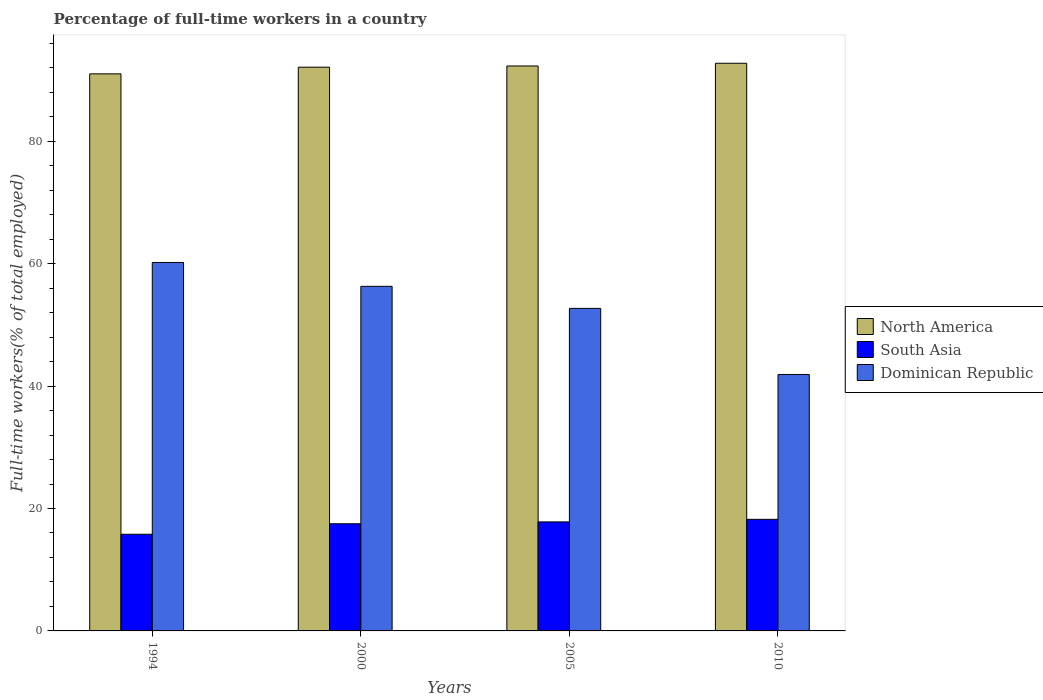Are the number of bars per tick equal to the number of legend labels?
Offer a very short reply. Yes. How many bars are there on the 4th tick from the left?
Give a very brief answer. 3. In how many cases, is the number of bars for a given year not equal to the number of legend labels?
Provide a short and direct response. 0. What is the percentage of full-time workers in South Asia in 2000?
Give a very brief answer. 17.51. Across all years, what is the maximum percentage of full-time workers in North America?
Give a very brief answer. 92.75. Across all years, what is the minimum percentage of full-time workers in Dominican Republic?
Offer a terse response. 41.9. What is the total percentage of full-time workers in North America in the graph?
Your response must be concise. 368.18. What is the difference between the percentage of full-time workers in South Asia in 2000 and that in 2005?
Ensure brevity in your answer.  -0.3. What is the difference between the percentage of full-time workers in North America in 2010 and the percentage of full-time workers in South Asia in 2005?
Your response must be concise. 74.94. What is the average percentage of full-time workers in North America per year?
Ensure brevity in your answer.  92.05. In the year 1994, what is the difference between the percentage of full-time workers in South Asia and percentage of full-time workers in North America?
Your answer should be very brief. -75.22. In how many years, is the percentage of full-time workers in South Asia greater than 88 %?
Offer a terse response. 0. What is the ratio of the percentage of full-time workers in North America in 2000 to that in 2005?
Keep it short and to the point. 1. Is the difference between the percentage of full-time workers in South Asia in 1994 and 2000 greater than the difference between the percentage of full-time workers in North America in 1994 and 2000?
Your response must be concise. No. What is the difference between the highest and the second highest percentage of full-time workers in South Asia?
Make the answer very short. 0.42. What is the difference between the highest and the lowest percentage of full-time workers in Dominican Republic?
Offer a very short reply. 18.3. What does the 2nd bar from the right in 1994 represents?
Give a very brief answer. South Asia. Is it the case that in every year, the sum of the percentage of full-time workers in North America and percentage of full-time workers in Dominican Republic is greater than the percentage of full-time workers in South Asia?
Offer a very short reply. Yes. Are all the bars in the graph horizontal?
Your answer should be compact. No. Are the values on the major ticks of Y-axis written in scientific E-notation?
Your answer should be very brief. No. Does the graph contain any zero values?
Your answer should be compact. No. Does the graph contain grids?
Offer a terse response. No. Where does the legend appear in the graph?
Your answer should be compact. Center right. What is the title of the graph?
Provide a short and direct response. Percentage of full-time workers in a country. What is the label or title of the X-axis?
Your answer should be compact. Years. What is the label or title of the Y-axis?
Your answer should be very brief. Full-time workers(% of total employed). What is the Full-time workers(% of total employed) in North America in 1994?
Provide a succinct answer. 91.02. What is the Full-time workers(% of total employed) of South Asia in 1994?
Keep it short and to the point. 15.79. What is the Full-time workers(% of total employed) of Dominican Republic in 1994?
Your answer should be very brief. 60.2. What is the Full-time workers(% of total employed) in North America in 2000?
Provide a succinct answer. 92.11. What is the Full-time workers(% of total employed) in South Asia in 2000?
Your answer should be very brief. 17.51. What is the Full-time workers(% of total employed) of Dominican Republic in 2000?
Make the answer very short. 56.3. What is the Full-time workers(% of total employed) in North America in 2005?
Your answer should be very brief. 92.31. What is the Full-time workers(% of total employed) of South Asia in 2005?
Ensure brevity in your answer.  17.81. What is the Full-time workers(% of total employed) in Dominican Republic in 2005?
Provide a short and direct response. 52.7. What is the Full-time workers(% of total employed) of North America in 2010?
Offer a terse response. 92.75. What is the Full-time workers(% of total employed) in South Asia in 2010?
Your response must be concise. 18.23. What is the Full-time workers(% of total employed) of Dominican Republic in 2010?
Your response must be concise. 41.9. Across all years, what is the maximum Full-time workers(% of total employed) of North America?
Your response must be concise. 92.75. Across all years, what is the maximum Full-time workers(% of total employed) in South Asia?
Provide a short and direct response. 18.23. Across all years, what is the maximum Full-time workers(% of total employed) of Dominican Republic?
Keep it short and to the point. 60.2. Across all years, what is the minimum Full-time workers(% of total employed) in North America?
Your answer should be compact. 91.02. Across all years, what is the minimum Full-time workers(% of total employed) of South Asia?
Offer a terse response. 15.79. Across all years, what is the minimum Full-time workers(% of total employed) of Dominican Republic?
Provide a succinct answer. 41.9. What is the total Full-time workers(% of total employed) of North America in the graph?
Provide a short and direct response. 368.18. What is the total Full-time workers(% of total employed) in South Asia in the graph?
Keep it short and to the point. 69.35. What is the total Full-time workers(% of total employed) in Dominican Republic in the graph?
Your answer should be compact. 211.1. What is the difference between the Full-time workers(% of total employed) in North America in 1994 and that in 2000?
Make the answer very short. -1.09. What is the difference between the Full-time workers(% of total employed) in South Asia in 1994 and that in 2000?
Offer a terse response. -1.72. What is the difference between the Full-time workers(% of total employed) of North America in 1994 and that in 2005?
Offer a very short reply. -1.29. What is the difference between the Full-time workers(% of total employed) in South Asia in 1994 and that in 2005?
Offer a terse response. -2.02. What is the difference between the Full-time workers(% of total employed) in North America in 1994 and that in 2010?
Keep it short and to the point. -1.73. What is the difference between the Full-time workers(% of total employed) of South Asia in 1994 and that in 2010?
Provide a succinct answer. -2.44. What is the difference between the Full-time workers(% of total employed) of Dominican Republic in 1994 and that in 2010?
Provide a succinct answer. 18.3. What is the difference between the Full-time workers(% of total employed) of North America in 2000 and that in 2005?
Ensure brevity in your answer.  -0.2. What is the difference between the Full-time workers(% of total employed) of South Asia in 2000 and that in 2005?
Provide a succinct answer. -0.3. What is the difference between the Full-time workers(% of total employed) of North America in 2000 and that in 2010?
Your answer should be compact. -0.64. What is the difference between the Full-time workers(% of total employed) of South Asia in 2000 and that in 2010?
Offer a very short reply. -0.72. What is the difference between the Full-time workers(% of total employed) of North America in 2005 and that in 2010?
Provide a succinct answer. -0.44. What is the difference between the Full-time workers(% of total employed) of South Asia in 2005 and that in 2010?
Your response must be concise. -0.42. What is the difference between the Full-time workers(% of total employed) in North America in 1994 and the Full-time workers(% of total employed) in South Asia in 2000?
Keep it short and to the point. 73.51. What is the difference between the Full-time workers(% of total employed) of North America in 1994 and the Full-time workers(% of total employed) of Dominican Republic in 2000?
Your response must be concise. 34.72. What is the difference between the Full-time workers(% of total employed) of South Asia in 1994 and the Full-time workers(% of total employed) of Dominican Republic in 2000?
Your answer should be compact. -40.51. What is the difference between the Full-time workers(% of total employed) in North America in 1994 and the Full-time workers(% of total employed) in South Asia in 2005?
Keep it short and to the point. 73.2. What is the difference between the Full-time workers(% of total employed) of North America in 1994 and the Full-time workers(% of total employed) of Dominican Republic in 2005?
Provide a succinct answer. 38.32. What is the difference between the Full-time workers(% of total employed) of South Asia in 1994 and the Full-time workers(% of total employed) of Dominican Republic in 2005?
Make the answer very short. -36.91. What is the difference between the Full-time workers(% of total employed) in North America in 1994 and the Full-time workers(% of total employed) in South Asia in 2010?
Provide a short and direct response. 72.79. What is the difference between the Full-time workers(% of total employed) of North America in 1994 and the Full-time workers(% of total employed) of Dominican Republic in 2010?
Provide a short and direct response. 49.12. What is the difference between the Full-time workers(% of total employed) of South Asia in 1994 and the Full-time workers(% of total employed) of Dominican Republic in 2010?
Give a very brief answer. -26.11. What is the difference between the Full-time workers(% of total employed) of North America in 2000 and the Full-time workers(% of total employed) of South Asia in 2005?
Ensure brevity in your answer.  74.3. What is the difference between the Full-time workers(% of total employed) of North America in 2000 and the Full-time workers(% of total employed) of Dominican Republic in 2005?
Keep it short and to the point. 39.41. What is the difference between the Full-time workers(% of total employed) in South Asia in 2000 and the Full-time workers(% of total employed) in Dominican Republic in 2005?
Make the answer very short. -35.19. What is the difference between the Full-time workers(% of total employed) in North America in 2000 and the Full-time workers(% of total employed) in South Asia in 2010?
Ensure brevity in your answer.  73.88. What is the difference between the Full-time workers(% of total employed) of North America in 2000 and the Full-time workers(% of total employed) of Dominican Republic in 2010?
Provide a short and direct response. 50.21. What is the difference between the Full-time workers(% of total employed) in South Asia in 2000 and the Full-time workers(% of total employed) in Dominican Republic in 2010?
Keep it short and to the point. -24.39. What is the difference between the Full-time workers(% of total employed) of North America in 2005 and the Full-time workers(% of total employed) of South Asia in 2010?
Keep it short and to the point. 74.07. What is the difference between the Full-time workers(% of total employed) of North America in 2005 and the Full-time workers(% of total employed) of Dominican Republic in 2010?
Provide a short and direct response. 50.41. What is the difference between the Full-time workers(% of total employed) in South Asia in 2005 and the Full-time workers(% of total employed) in Dominican Republic in 2010?
Give a very brief answer. -24.09. What is the average Full-time workers(% of total employed) in North America per year?
Offer a terse response. 92.05. What is the average Full-time workers(% of total employed) of South Asia per year?
Provide a short and direct response. 17.34. What is the average Full-time workers(% of total employed) in Dominican Republic per year?
Keep it short and to the point. 52.77. In the year 1994, what is the difference between the Full-time workers(% of total employed) in North America and Full-time workers(% of total employed) in South Asia?
Provide a succinct answer. 75.22. In the year 1994, what is the difference between the Full-time workers(% of total employed) in North America and Full-time workers(% of total employed) in Dominican Republic?
Your response must be concise. 30.82. In the year 1994, what is the difference between the Full-time workers(% of total employed) in South Asia and Full-time workers(% of total employed) in Dominican Republic?
Offer a very short reply. -44.41. In the year 2000, what is the difference between the Full-time workers(% of total employed) in North America and Full-time workers(% of total employed) in South Asia?
Give a very brief answer. 74.6. In the year 2000, what is the difference between the Full-time workers(% of total employed) of North America and Full-time workers(% of total employed) of Dominican Republic?
Offer a terse response. 35.81. In the year 2000, what is the difference between the Full-time workers(% of total employed) in South Asia and Full-time workers(% of total employed) in Dominican Republic?
Your response must be concise. -38.79. In the year 2005, what is the difference between the Full-time workers(% of total employed) of North America and Full-time workers(% of total employed) of South Asia?
Offer a very short reply. 74.49. In the year 2005, what is the difference between the Full-time workers(% of total employed) of North America and Full-time workers(% of total employed) of Dominican Republic?
Keep it short and to the point. 39.61. In the year 2005, what is the difference between the Full-time workers(% of total employed) of South Asia and Full-time workers(% of total employed) of Dominican Republic?
Provide a succinct answer. -34.89. In the year 2010, what is the difference between the Full-time workers(% of total employed) of North America and Full-time workers(% of total employed) of South Asia?
Offer a terse response. 74.52. In the year 2010, what is the difference between the Full-time workers(% of total employed) of North America and Full-time workers(% of total employed) of Dominican Republic?
Your answer should be compact. 50.85. In the year 2010, what is the difference between the Full-time workers(% of total employed) in South Asia and Full-time workers(% of total employed) in Dominican Republic?
Your answer should be compact. -23.67. What is the ratio of the Full-time workers(% of total employed) of South Asia in 1994 to that in 2000?
Give a very brief answer. 0.9. What is the ratio of the Full-time workers(% of total employed) in Dominican Republic in 1994 to that in 2000?
Your response must be concise. 1.07. What is the ratio of the Full-time workers(% of total employed) of North America in 1994 to that in 2005?
Make the answer very short. 0.99. What is the ratio of the Full-time workers(% of total employed) of South Asia in 1994 to that in 2005?
Make the answer very short. 0.89. What is the ratio of the Full-time workers(% of total employed) of Dominican Republic in 1994 to that in 2005?
Offer a terse response. 1.14. What is the ratio of the Full-time workers(% of total employed) of North America in 1994 to that in 2010?
Your answer should be very brief. 0.98. What is the ratio of the Full-time workers(% of total employed) in South Asia in 1994 to that in 2010?
Offer a very short reply. 0.87. What is the ratio of the Full-time workers(% of total employed) in Dominican Republic in 1994 to that in 2010?
Give a very brief answer. 1.44. What is the ratio of the Full-time workers(% of total employed) in North America in 2000 to that in 2005?
Provide a succinct answer. 1. What is the ratio of the Full-time workers(% of total employed) of South Asia in 2000 to that in 2005?
Your answer should be compact. 0.98. What is the ratio of the Full-time workers(% of total employed) in Dominican Republic in 2000 to that in 2005?
Ensure brevity in your answer.  1.07. What is the ratio of the Full-time workers(% of total employed) in North America in 2000 to that in 2010?
Provide a short and direct response. 0.99. What is the ratio of the Full-time workers(% of total employed) in South Asia in 2000 to that in 2010?
Ensure brevity in your answer.  0.96. What is the ratio of the Full-time workers(% of total employed) in Dominican Republic in 2000 to that in 2010?
Give a very brief answer. 1.34. What is the ratio of the Full-time workers(% of total employed) in North America in 2005 to that in 2010?
Make the answer very short. 1. What is the ratio of the Full-time workers(% of total employed) of South Asia in 2005 to that in 2010?
Provide a succinct answer. 0.98. What is the ratio of the Full-time workers(% of total employed) of Dominican Republic in 2005 to that in 2010?
Your answer should be compact. 1.26. What is the difference between the highest and the second highest Full-time workers(% of total employed) of North America?
Your answer should be compact. 0.44. What is the difference between the highest and the second highest Full-time workers(% of total employed) of South Asia?
Ensure brevity in your answer.  0.42. What is the difference between the highest and the second highest Full-time workers(% of total employed) of Dominican Republic?
Your answer should be very brief. 3.9. What is the difference between the highest and the lowest Full-time workers(% of total employed) of North America?
Your answer should be compact. 1.73. What is the difference between the highest and the lowest Full-time workers(% of total employed) of South Asia?
Make the answer very short. 2.44. 